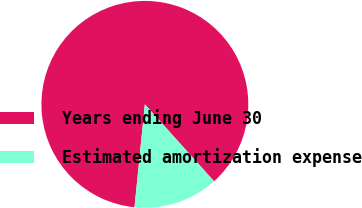<chart> <loc_0><loc_0><loc_500><loc_500><pie_chart><fcel>Years ending June 30<fcel>Estimated amortization expense<nl><fcel>86.74%<fcel>13.26%<nl></chart> 